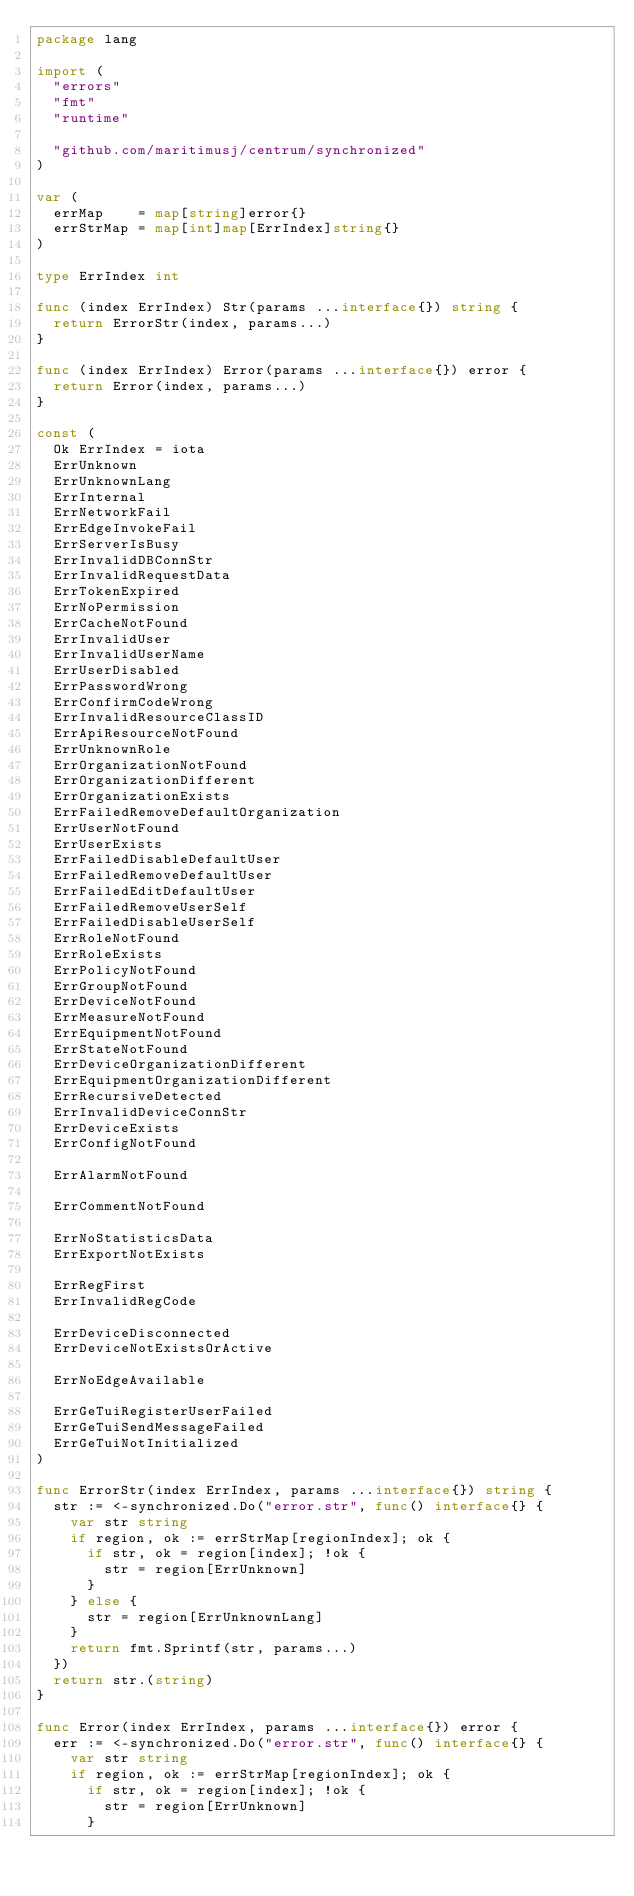<code> <loc_0><loc_0><loc_500><loc_500><_Go_>package lang

import (
	"errors"
	"fmt"
	"runtime"

	"github.com/maritimusj/centrum/synchronized"
)

var (
	errMap    = map[string]error{}
	errStrMap = map[int]map[ErrIndex]string{}
)

type ErrIndex int

func (index ErrIndex) Str(params ...interface{}) string {
	return ErrorStr(index, params...)
}

func (index ErrIndex) Error(params ...interface{}) error {
	return Error(index, params...)
}

const (
	Ok ErrIndex = iota
	ErrUnknown
	ErrUnknownLang
	ErrInternal
	ErrNetworkFail
	ErrEdgeInvokeFail
	ErrServerIsBusy
	ErrInvalidDBConnStr
	ErrInvalidRequestData
	ErrTokenExpired
	ErrNoPermission
	ErrCacheNotFound
	ErrInvalidUser
	ErrInvalidUserName
	ErrUserDisabled
	ErrPasswordWrong
	ErrConfirmCodeWrong
	ErrInvalidResourceClassID
	ErrApiResourceNotFound
	ErrUnknownRole
	ErrOrganizationNotFound
	ErrOrganizationDifferent
	ErrOrganizationExists
	ErrFailedRemoveDefaultOrganization
	ErrUserNotFound
	ErrUserExists
	ErrFailedDisableDefaultUser
	ErrFailedRemoveDefaultUser
	ErrFailedEditDefaultUser
	ErrFailedRemoveUserSelf
	ErrFailedDisableUserSelf
	ErrRoleNotFound
	ErrRoleExists
	ErrPolicyNotFound
	ErrGroupNotFound
	ErrDeviceNotFound
	ErrMeasureNotFound
	ErrEquipmentNotFound
	ErrStateNotFound
	ErrDeviceOrganizationDifferent
	ErrEquipmentOrganizationDifferent
	ErrRecursiveDetected
	ErrInvalidDeviceConnStr
	ErrDeviceExists
	ErrConfigNotFound

	ErrAlarmNotFound

	ErrCommentNotFound

	ErrNoStatisticsData
	ErrExportNotExists

	ErrRegFirst
	ErrInvalidRegCode

	ErrDeviceDisconnected
	ErrDeviceNotExistsOrActive

	ErrNoEdgeAvailable

	ErrGeTuiRegisterUserFailed
	ErrGeTuiSendMessageFailed
	ErrGeTuiNotInitialized
)

func ErrorStr(index ErrIndex, params ...interface{}) string {
	str := <-synchronized.Do("error.str", func() interface{} {
		var str string
		if region, ok := errStrMap[regionIndex]; ok {
			if str, ok = region[index]; !ok {
				str = region[ErrUnknown]
			}
		} else {
			str = region[ErrUnknownLang]
		}
		return fmt.Sprintf(str, params...)
	})
	return str.(string)
}

func Error(index ErrIndex, params ...interface{}) error {
	err := <-synchronized.Do("error.str", func() interface{} {
		var str string
		if region, ok := errStrMap[regionIndex]; ok {
			if str, ok = region[index]; !ok {
				str = region[ErrUnknown]
			}</code> 